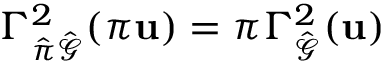<formula> <loc_0><loc_0><loc_500><loc_500>\Gamma _ { \hat { \pi } \hat { \mathcal { G } } } ^ { 2 } ( \pi u ) = \pi \Gamma _ { \hat { \mathcal { G } } } ^ { 2 } ( u )</formula> 